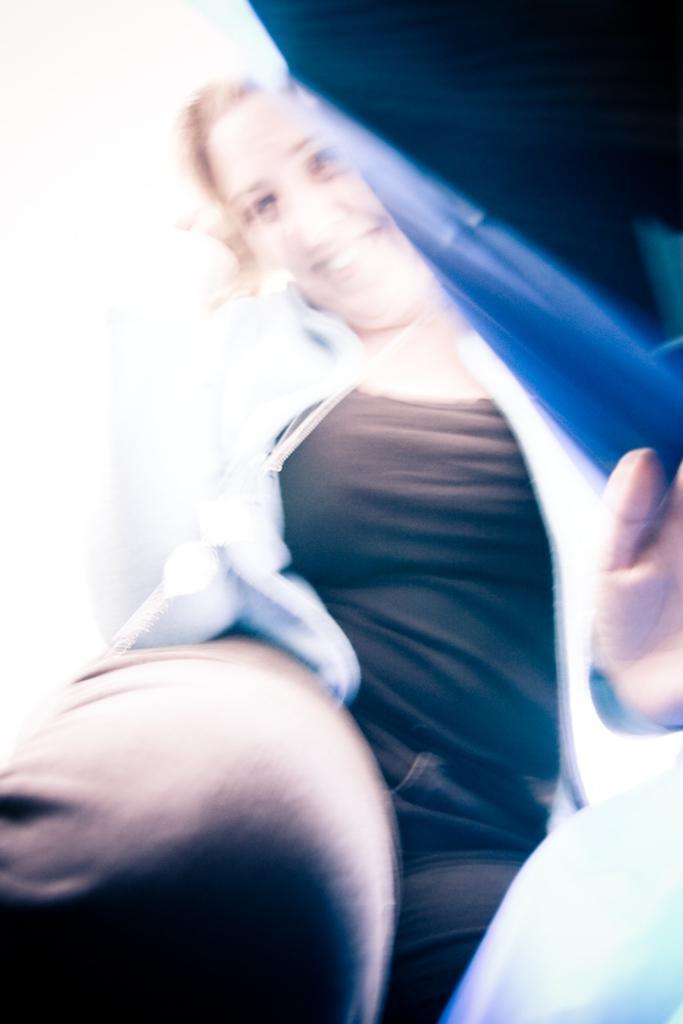Could you give a brief overview of what you see in this image? In the picture we can see a woman standing, she is with black T-shirt and white shirt and removing a blue color cover and smiling. 